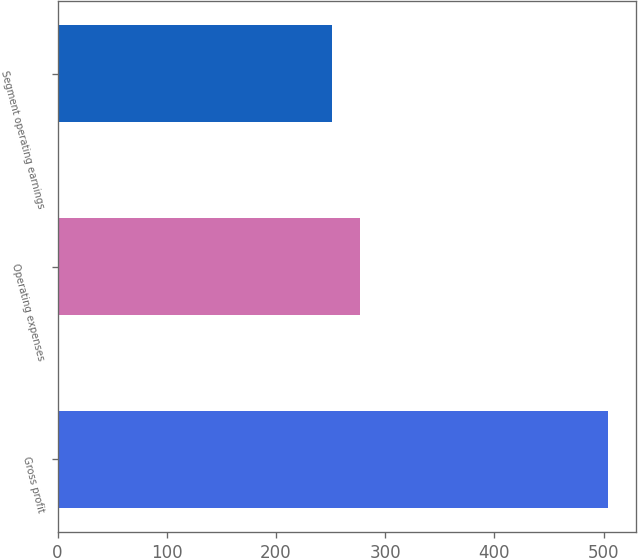<chart> <loc_0><loc_0><loc_500><loc_500><bar_chart><fcel>Gross profit<fcel>Operating expenses<fcel>Segment operating earnings<nl><fcel>504.3<fcel>276.51<fcel>251.2<nl></chart> 